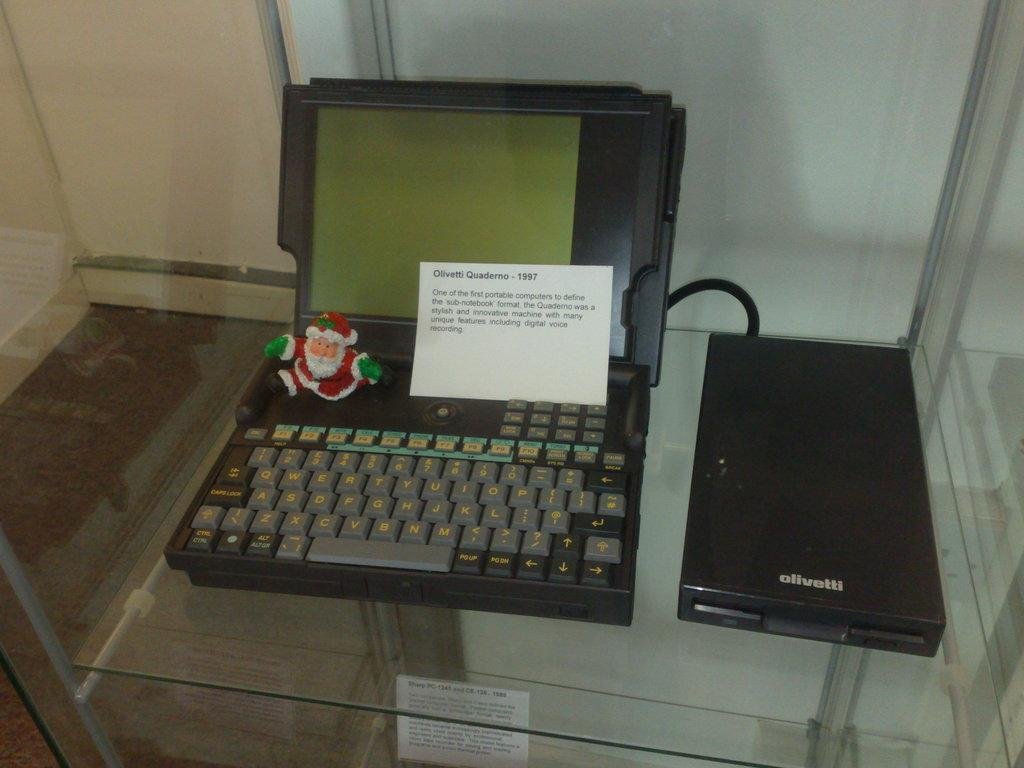<image>
Create a compact narrative representing the image presented. Black box with the word "Olivetti" next to a black laptop. 